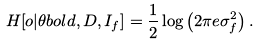Convert formula to latex. <formula><loc_0><loc_0><loc_500><loc_500>H [ o | \theta b o l d , D , I _ { f } ] = \frac { 1 } { 2 } \log \left ( 2 \pi e \sigma _ { f } ^ { 2 } \right ) .</formula> 